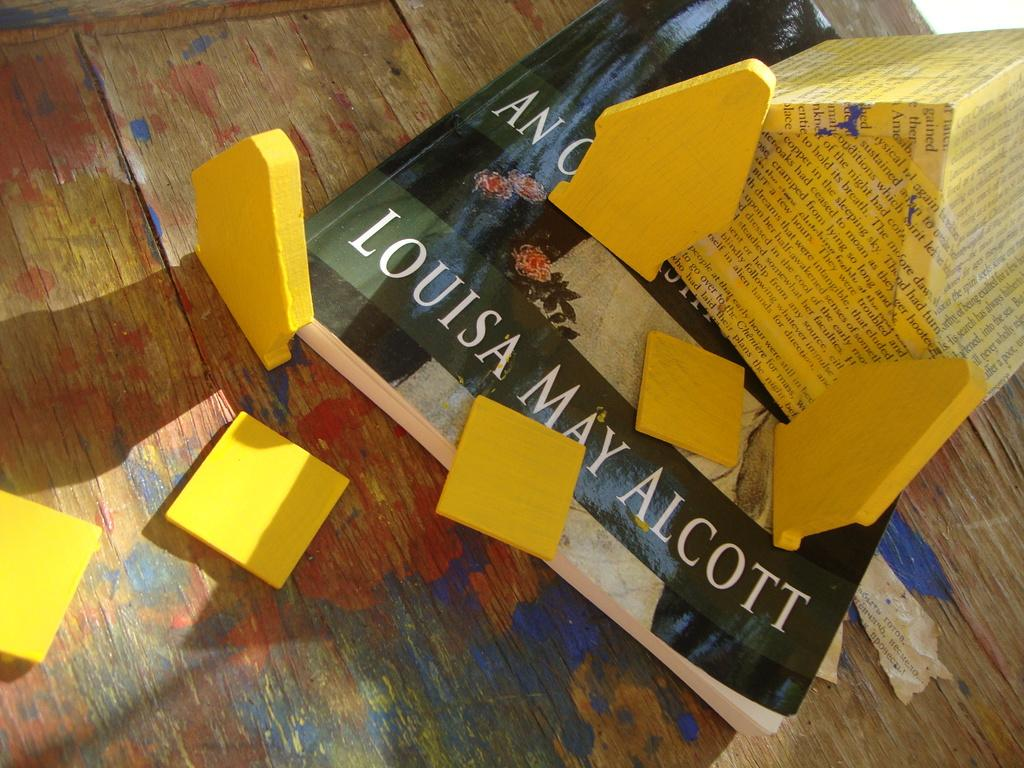<image>
Summarize the visual content of the image. A yellow paper house, trees and walkway sit atop a Louisa May Alcott book. 